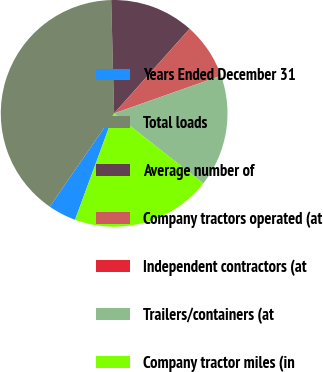<chart> <loc_0><loc_0><loc_500><loc_500><pie_chart><fcel>Years Ended December 31<fcel>Total loads<fcel>Average number of<fcel>Company tractors operated (at<fcel>Independent contractors (at<fcel>Trailers/containers (at<fcel>Company tractor miles (in<nl><fcel>4.01%<fcel>39.97%<fcel>12.0%<fcel>8.01%<fcel>0.01%<fcel>16.0%<fcel>19.99%<nl></chart> 